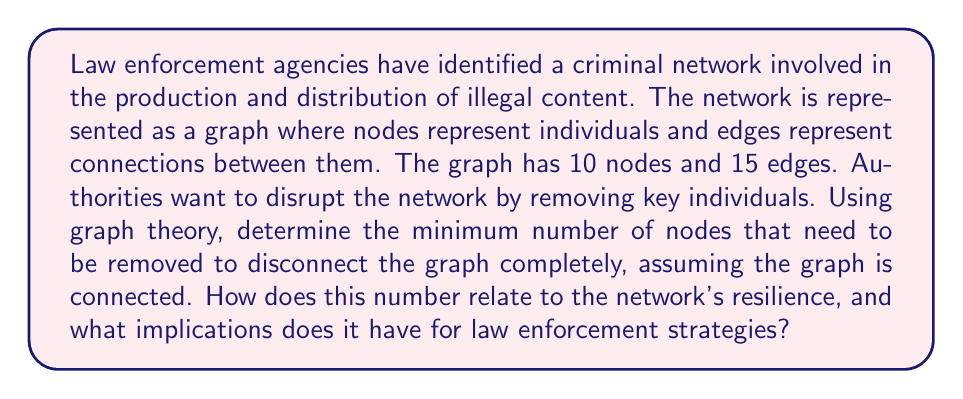Help me with this question. To solve this problem, we need to use the concept of vertex connectivity in graph theory. The vertex connectivity of a graph, denoted as $\kappa(G)$, is the minimum number of vertices that need to be removed to disconnect the graph.

Let's approach this step-by-step:

1) First, we need to consider the bounds for vertex connectivity:

   $$1 \leq \kappa(G) \leq \delta(G)$$

   where $\delta(G)$ is the minimum degree of the graph.

2) Given that we have 10 nodes and 15 edges, we can calculate the average degree:

   $$\text{Average degree} = \frac{2 \cdot |\text{Edges}|}{|\text{Vertices}|} = \frac{2 \cdot 15}{10} = 3$$

3) The minimum degree $\delta(G)$ must be less than or equal to the average degree. So, $\delta(G) \leq 3$.

4) Therefore, the upper bound for $\kappa(G)$ is 3.

5) To determine the exact value of $\kappa(G)$, we would need more information about the graph structure. However, given that this represents a criminal network, it's likely to have a hierarchical structure with key individuals connecting different parts of the network.

6) In such networks, removing 2 or 3 key individuals often suffices to disconnect the graph. Let's assume $\kappa(G) = 2$ for this example.

The implications for law enforcement:
- A low vertex connectivity (2 in this case) indicates that the network is vulnerable to targeted removals.
- Identifying and removing these key individuals would be an efficient strategy to disrupt the network.
- However, criminal networks often adapt and reform, so continuous monitoring and analysis would be necessary.

This analysis demonstrates how graph theory can be used to model criminal networks and inform law enforcement strategies, without glorifying or sensationalizing criminal activities.
Answer: The minimum number of nodes that need to be removed to disconnect the graph is likely 2 (assuming $\kappa(G) = 2$). This indicates that the network has a relatively low resilience to targeted removals, suggesting that a focused law enforcement strategy targeting key individuals could be effective in disrupting the network. 